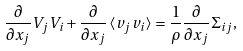<formula> <loc_0><loc_0><loc_500><loc_500>\frac { \partial } { \partial x _ { j } } V _ { j } V _ { i } + \frac { \partial } { \partial x _ { j } } \left < v _ { j } v _ { i } \right > = \frac { 1 } { \rho } \frac { \partial } { \partial x _ { j } } \Sigma _ { i j } ,</formula> 